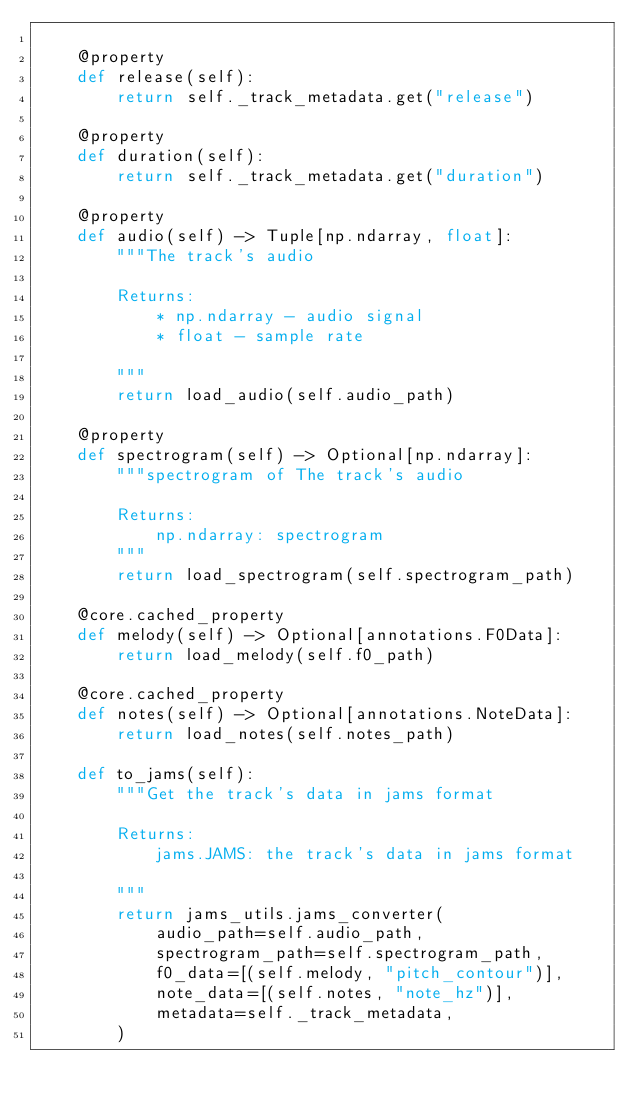Convert code to text. <code><loc_0><loc_0><loc_500><loc_500><_Python_>
    @property
    def release(self):
        return self._track_metadata.get("release")

    @property
    def duration(self):
        return self._track_metadata.get("duration")

    @property
    def audio(self) -> Tuple[np.ndarray, float]:
        """The track's audio

        Returns:
            * np.ndarray - audio signal
            * float - sample rate

        """
        return load_audio(self.audio_path)

    @property
    def spectrogram(self) -> Optional[np.ndarray]:
        """spectrogram of The track's audio

        Returns:
            np.ndarray: spectrogram
        """
        return load_spectrogram(self.spectrogram_path)

    @core.cached_property
    def melody(self) -> Optional[annotations.F0Data]:
        return load_melody(self.f0_path)

    @core.cached_property
    def notes(self) -> Optional[annotations.NoteData]:
        return load_notes(self.notes_path)

    def to_jams(self):
        """Get the track's data in jams format

        Returns:
            jams.JAMS: the track's data in jams format

        """
        return jams_utils.jams_converter(
            audio_path=self.audio_path,
            spectrogram_path=self.spectrogram_path,
            f0_data=[(self.melody, "pitch_contour")],
            note_data=[(self.notes, "note_hz")],
            metadata=self._track_metadata,
        )

</code> 